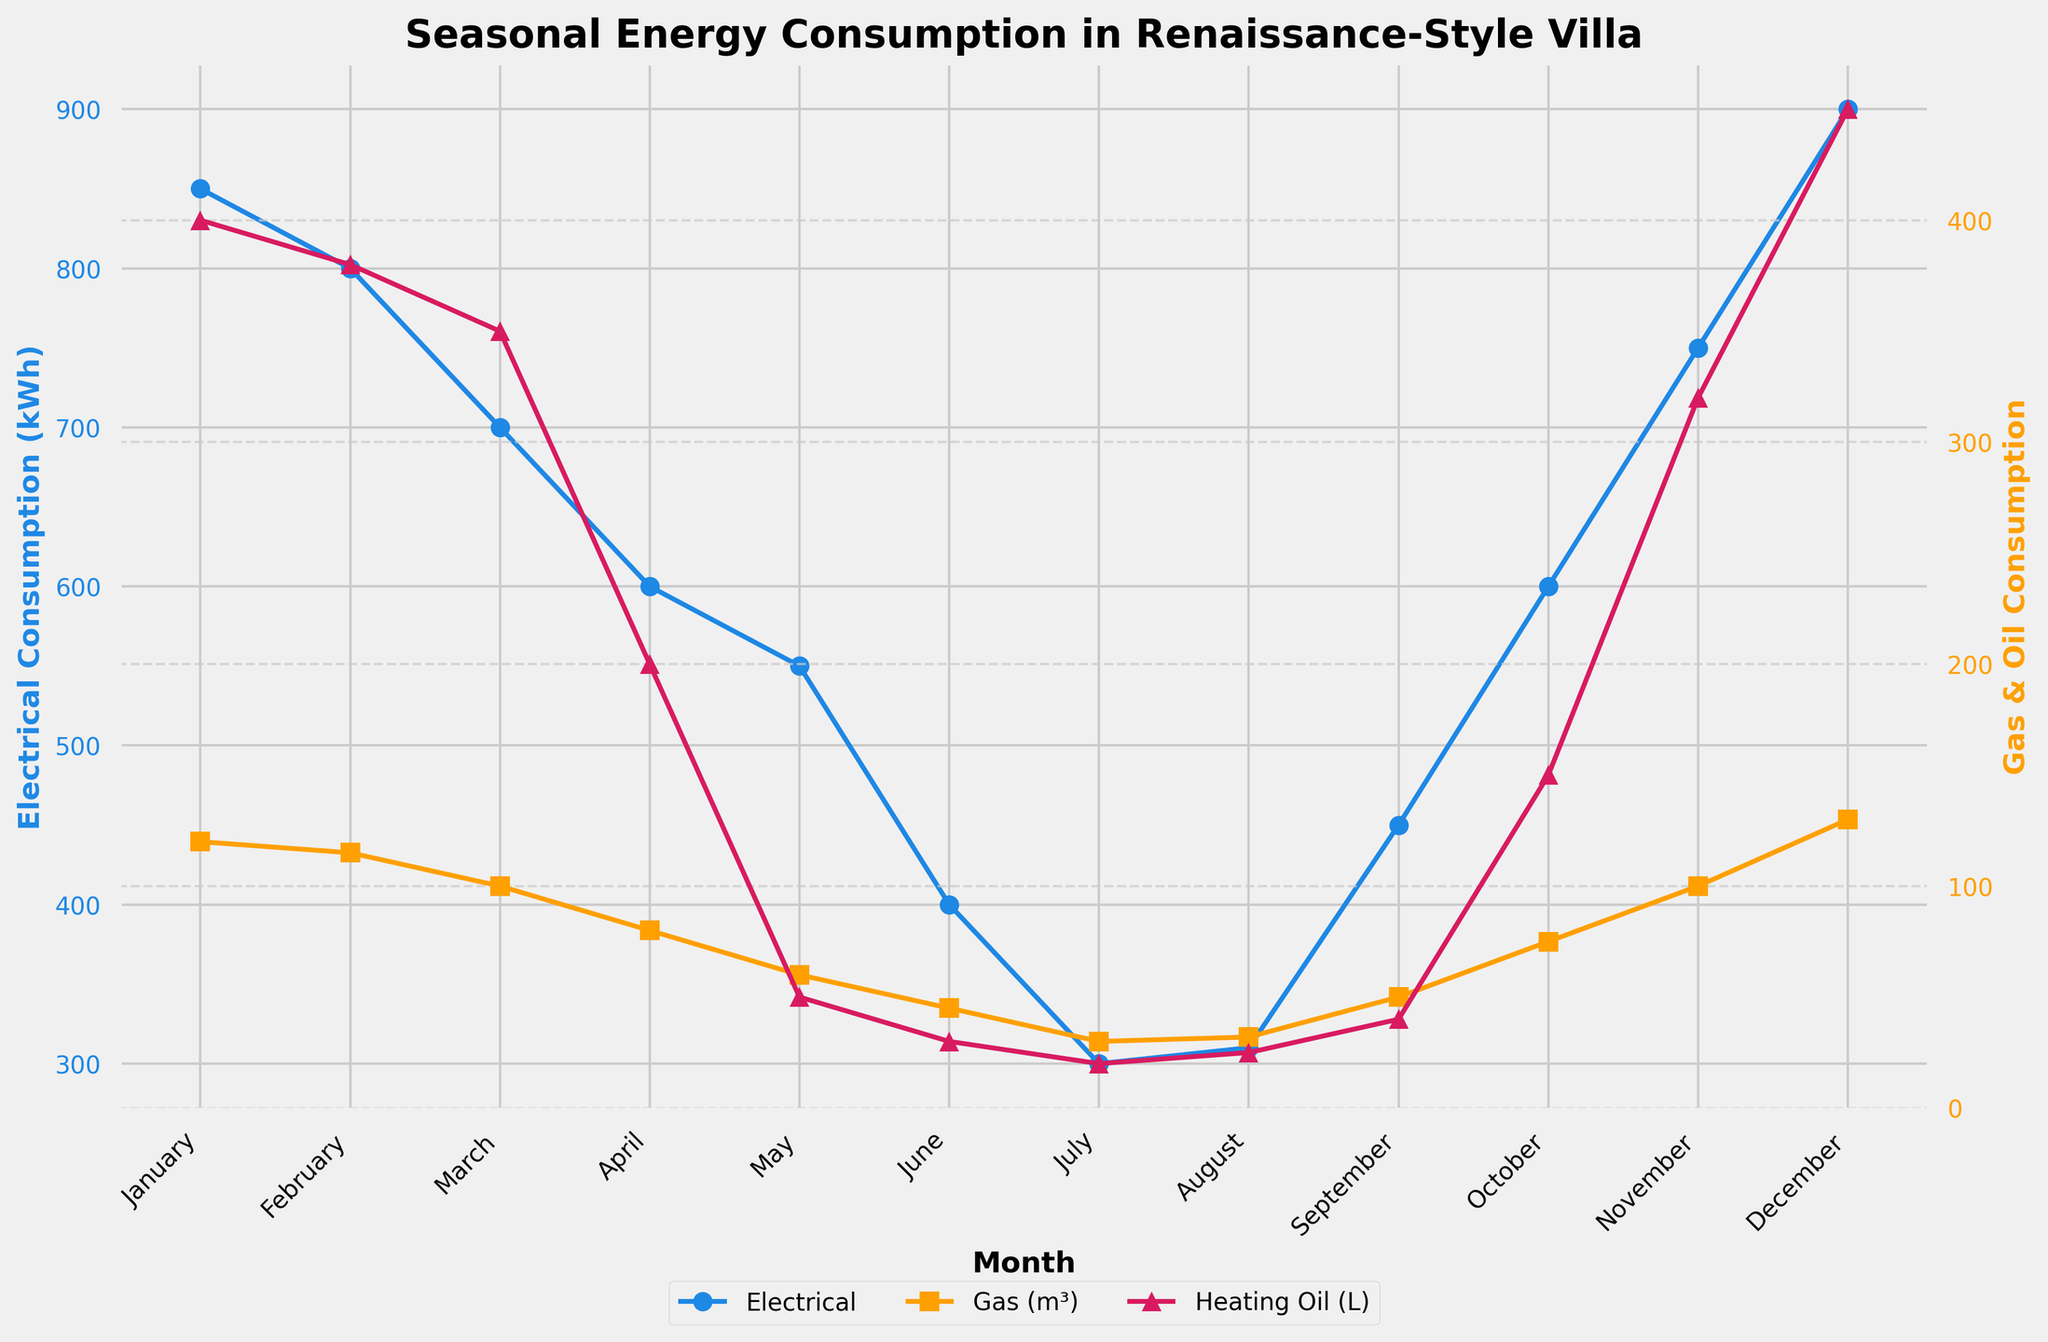What is the month with the highest electrical consumption? The plot shows the monthly electrical consumption with connected blue dots. The highest point in this series appears in December, indicating the maximum consumption.
Answer: December Which month has the lowest heating oil consumption? The plot shows the heating oil consumption using a series of connected magenta triangles. The lowest point on this series is in July, indicating the minimum consumption.
Answer: July What is the difference between electrical consumption in January and July? From the plot, the electrical consumption in January is 850 kWh and in July is 300 kWh. The difference is thus 850 - 300.
Answer: 550 kWh How does gas consumption in February compare to October? The gas consumption in February is 115 m³, while in October it is 75 m³. Therefore, February has higher gas consumption.
Answer: February has higher consumption What's the average electrical consumption over the year? Sum the electrical consumption for all months and divide by 12. (850 + 800 + 700 + 600 + 550 + 400 + 300 + 310 + 450 + 600 + 750 + 900) / 12
Answer: 583.33 kWh During which season is the heating oil consumption the highest? High heating oil consumption is shown in November, December, January, and February on the plot. These months fall in winter, indicating maximal heating oil usage during this season.
Answer: Winter What is the combined gas consumption in the summer months (June, July, and August)? By summing June (45 m³), July (30 m³), and August (32 m³) gas consumption, we get a total. 45 + 30 + 32 = 107
Answer: 107 m³ How does electrical consumption change from April to May? The plot shows the electrical consumption decreases from 600 kWh in April to 550 kWh in May.
Answer: Decreases Which month has the second lowest gas consumption? The plot points to June as having the lowest gas consumption (45 m³), with July having the second lowest (30 m³).
Answer: July 